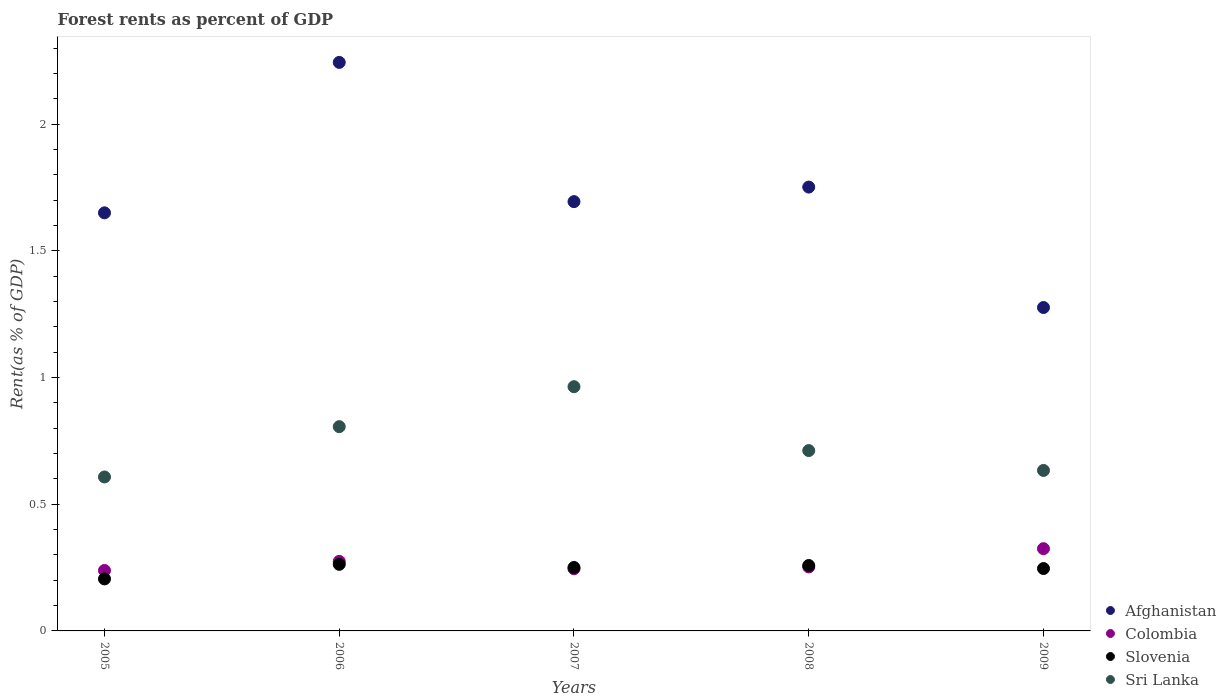Is the number of dotlines equal to the number of legend labels?
Give a very brief answer. Yes. What is the forest rent in Slovenia in 2005?
Make the answer very short. 0.21. Across all years, what is the maximum forest rent in Slovenia?
Give a very brief answer. 0.26. Across all years, what is the minimum forest rent in Sri Lanka?
Keep it short and to the point. 0.61. In which year was the forest rent in Afghanistan minimum?
Provide a succinct answer. 2009. What is the total forest rent in Afghanistan in the graph?
Keep it short and to the point. 8.62. What is the difference between the forest rent in Slovenia in 2007 and that in 2009?
Your answer should be very brief. 0. What is the difference between the forest rent in Colombia in 2005 and the forest rent in Afghanistan in 2008?
Ensure brevity in your answer.  -1.51. What is the average forest rent in Slovenia per year?
Your answer should be compact. 0.24. In the year 2007, what is the difference between the forest rent in Sri Lanka and forest rent in Afghanistan?
Keep it short and to the point. -0.73. In how many years, is the forest rent in Sri Lanka greater than 1.2 %?
Offer a terse response. 0. What is the ratio of the forest rent in Slovenia in 2005 to that in 2009?
Offer a very short reply. 0.83. Is the forest rent in Slovenia in 2006 less than that in 2008?
Your answer should be very brief. No. What is the difference between the highest and the second highest forest rent in Afghanistan?
Make the answer very short. 0.49. What is the difference between the highest and the lowest forest rent in Afghanistan?
Offer a terse response. 0.97. Is the sum of the forest rent in Slovenia in 2008 and 2009 greater than the maximum forest rent in Colombia across all years?
Your answer should be very brief. Yes. Is it the case that in every year, the sum of the forest rent in Sri Lanka and forest rent in Afghanistan  is greater than the sum of forest rent in Colombia and forest rent in Slovenia?
Provide a short and direct response. No. Is it the case that in every year, the sum of the forest rent in Sri Lanka and forest rent in Afghanistan  is greater than the forest rent in Colombia?
Give a very brief answer. Yes. Does the forest rent in Slovenia monotonically increase over the years?
Your response must be concise. No. Is the forest rent in Colombia strictly less than the forest rent in Sri Lanka over the years?
Ensure brevity in your answer.  Yes. Are the values on the major ticks of Y-axis written in scientific E-notation?
Provide a succinct answer. No. Does the graph contain grids?
Your response must be concise. No. What is the title of the graph?
Your answer should be very brief. Forest rents as percent of GDP. What is the label or title of the X-axis?
Your answer should be compact. Years. What is the label or title of the Y-axis?
Ensure brevity in your answer.  Rent(as % of GDP). What is the Rent(as % of GDP) of Afghanistan in 2005?
Ensure brevity in your answer.  1.65. What is the Rent(as % of GDP) of Colombia in 2005?
Give a very brief answer. 0.24. What is the Rent(as % of GDP) of Slovenia in 2005?
Your answer should be compact. 0.21. What is the Rent(as % of GDP) in Sri Lanka in 2005?
Your answer should be compact. 0.61. What is the Rent(as % of GDP) of Afghanistan in 2006?
Your response must be concise. 2.24. What is the Rent(as % of GDP) of Colombia in 2006?
Provide a succinct answer. 0.27. What is the Rent(as % of GDP) of Slovenia in 2006?
Your response must be concise. 0.26. What is the Rent(as % of GDP) in Sri Lanka in 2006?
Offer a very short reply. 0.81. What is the Rent(as % of GDP) of Afghanistan in 2007?
Offer a very short reply. 1.69. What is the Rent(as % of GDP) in Colombia in 2007?
Keep it short and to the point. 0.25. What is the Rent(as % of GDP) of Slovenia in 2007?
Your response must be concise. 0.25. What is the Rent(as % of GDP) in Sri Lanka in 2007?
Provide a succinct answer. 0.96. What is the Rent(as % of GDP) of Afghanistan in 2008?
Keep it short and to the point. 1.75. What is the Rent(as % of GDP) of Colombia in 2008?
Provide a short and direct response. 0.25. What is the Rent(as % of GDP) in Slovenia in 2008?
Keep it short and to the point. 0.26. What is the Rent(as % of GDP) of Sri Lanka in 2008?
Ensure brevity in your answer.  0.71. What is the Rent(as % of GDP) in Afghanistan in 2009?
Your answer should be compact. 1.28. What is the Rent(as % of GDP) of Colombia in 2009?
Provide a succinct answer. 0.32. What is the Rent(as % of GDP) in Slovenia in 2009?
Provide a succinct answer. 0.25. What is the Rent(as % of GDP) in Sri Lanka in 2009?
Provide a succinct answer. 0.63. Across all years, what is the maximum Rent(as % of GDP) in Afghanistan?
Make the answer very short. 2.24. Across all years, what is the maximum Rent(as % of GDP) of Colombia?
Offer a very short reply. 0.32. Across all years, what is the maximum Rent(as % of GDP) in Slovenia?
Your answer should be very brief. 0.26. Across all years, what is the maximum Rent(as % of GDP) of Sri Lanka?
Your answer should be very brief. 0.96. Across all years, what is the minimum Rent(as % of GDP) in Afghanistan?
Your answer should be very brief. 1.28. Across all years, what is the minimum Rent(as % of GDP) in Colombia?
Your answer should be compact. 0.24. Across all years, what is the minimum Rent(as % of GDP) of Slovenia?
Your answer should be very brief. 0.21. Across all years, what is the minimum Rent(as % of GDP) in Sri Lanka?
Provide a succinct answer. 0.61. What is the total Rent(as % of GDP) in Afghanistan in the graph?
Provide a short and direct response. 8.62. What is the total Rent(as % of GDP) of Colombia in the graph?
Provide a short and direct response. 1.34. What is the total Rent(as % of GDP) in Slovenia in the graph?
Offer a very short reply. 1.22. What is the total Rent(as % of GDP) in Sri Lanka in the graph?
Ensure brevity in your answer.  3.72. What is the difference between the Rent(as % of GDP) in Afghanistan in 2005 and that in 2006?
Ensure brevity in your answer.  -0.59. What is the difference between the Rent(as % of GDP) of Colombia in 2005 and that in 2006?
Your answer should be very brief. -0.04. What is the difference between the Rent(as % of GDP) of Slovenia in 2005 and that in 2006?
Offer a very short reply. -0.06. What is the difference between the Rent(as % of GDP) of Sri Lanka in 2005 and that in 2006?
Provide a short and direct response. -0.2. What is the difference between the Rent(as % of GDP) of Afghanistan in 2005 and that in 2007?
Your answer should be very brief. -0.04. What is the difference between the Rent(as % of GDP) in Colombia in 2005 and that in 2007?
Provide a short and direct response. -0.01. What is the difference between the Rent(as % of GDP) of Slovenia in 2005 and that in 2007?
Offer a terse response. -0.05. What is the difference between the Rent(as % of GDP) of Sri Lanka in 2005 and that in 2007?
Ensure brevity in your answer.  -0.36. What is the difference between the Rent(as % of GDP) of Afghanistan in 2005 and that in 2008?
Your answer should be compact. -0.1. What is the difference between the Rent(as % of GDP) of Colombia in 2005 and that in 2008?
Give a very brief answer. -0.01. What is the difference between the Rent(as % of GDP) in Slovenia in 2005 and that in 2008?
Offer a terse response. -0.05. What is the difference between the Rent(as % of GDP) of Sri Lanka in 2005 and that in 2008?
Your answer should be compact. -0.1. What is the difference between the Rent(as % of GDP) of Afghanistan in 2005 and that in 2009?
Provide a short and direct response. 0.37. What is the difference between the Rent(as % of GDP) of Colombia in 2005 and that in 2009?
Your response must be concise. -0.09. What is the difference between the Rent(as % of GDP) in Slovenia in 2005 and that in 2009?
Give a very brief answer. -0.04. What is the difference between the Rent(as % of GDP) in Sri Lanka in 2005 and that in 2009?
Provide a succinct answer. -0.03. What is the difference between the Rent(as % of GDP) of Afghanistan in 2006 and that in 2007?
Offer a very short reply. 0.55. What is the difference between the Rent(as % of GDP) of Colombia in 2006 and that in 2007?
Your answer should be very brief. 0.03. What is the difference between the Rent(as % of GDP) of Slovenia in 2006 and that in 2007?
Make the answer very short. 0.01. What is the difference between the Rent(as % of GDP) of Sri Lanka in 2006 and that in 2007?
Provide a short and direct response. -0.16. What is the difference between the Rent(as % of GDP) in Afghanistan in 2006 and that in 2008?
Ensure brevity in your answer.  0.49. What is the difference between the Rent(as % of GDP) of Colombia in 2006 and that in 2008?
Make the answer very short. 0.02. What is the difference between the Rent(as % of GDP) of Slovenia in 2006 and that in 2008?
Make the answer very short. 0. What is the difference between the Rent(as % of GDP) of Sri Lanka in 2006 and that in 2008?
Provide a succinct answer. 0.09. What is the difference between the Rent(as % of GDP) in Colombia in 2006 and that in 2009?
Give a very brief answer. -0.05. What is the difference between the Rent(as % of GDP) of Slovenia in 2006 and that in 2009?
Your response must be concise. 0.02. What is the difference between the Rent(as % of GDP) of Sri Lanka in 2006 and that in 2009?
Give a very brief answer. 0.17. What is the difference between the Rent(as % of GDP) of Afghanistan in 2007 and that in 2008?
Provide a succinct answer. -0.06. What is the difference between the Rent(as % of GDP) in Colombia in 2007 and that in 2008?
Make the answer very short. -0.01. What is the difference between the Rent(as % of GDP) in Slovenia in 2007 and that in 2008?
Your response must be concise. -0.01. What is the difference between the Rent(as % of GDP) of Sri Lanka in 2007 and that in 2008?
Your answer should be compact. 0.25. What is the difference between the Rent(as % of GDP) of Afghanistan in 2007 and that in 2009?
Keep it short and to the point. 0.42. What is the difference between the Rent(as % of GDP) in Colombia in 2007 and that in 2009?
Offer a terse response. -0.08. What is the difference between the Rent(as % of GDP) of Slovenia in 2007 and that in 2009?
Offer a terse response. 0. What is the difference between the Rent(as % of GDP) in Sri Lanka in 2007 and that in 2009?
Give a very brief answer. 0.33. What is the difference between the Rent(as % of GDP) in Afghanistan in 2008 and that in 2009?
Provide a succinct answer. 0.48. What is the difference between the Rent(as % of GDP) in Colombia in 2008 and that in 2009?
Your answer should be compact. -0.07. What is the difference between the Rent(as % of GDP) of Slovenia in 2008 and that in 2009?
Provide a short and direct response. 0.01. What is the difference between the Rent(as % of GDP) in Sri Lanka in 2008 and that in 2009?
Make the answer very short. 0.08. What is the difference between the Rent(as % of GDP) in Afghanistan in 2005 and the Rent(as % of GDP) in Colombia in 2006?
Provide a succinct answer. 1.38. What is the difference between the Rent(as % of GDP) in Afghanistan in 2005 and the Rent(as % of GDP) in Slovenia in 2006?
Your answer should be very brief. 1.39. What is the difference between the Rent(as % of GDP) in Afghanistan in 2005 and the Rent(as % of GDP) in Sri Lanka in 2006?
Offer a very short reply. 0.84. What is the difference between the Rent(as % of GDP) of Colombia in 2005 and the Rent(as % of GDP) of Slovenia in 2006?
Ensure brevity in your answer.  -0.02. What is the difference between the Rent(as % of GDP) in Colombia in 2005 and the Rent(as % of GDP) in Sri Lanka in 2006?
Your answer should be very brief. -0.57. What is the difference between the Rent(as % of GDP) of Slovenia in 2005 and the Rent(as % of GDP) of Sri Lanka in 2006?
Provide a short and direct response. -0.6. What is the difference between the Rent(as % of GDP) of Afghanistan in 2005 and the Rent(as % of GDP) of Colombia in 2007?
Offer a terse response. 1.41. What is the difference between the Rent(as % of GDP) of Afghanistan in 2005 and the Rent(as % of GDP) of Slovenia in 2007?
Your answer should be compact. 1.4. What is the difference between the Rent(as % of GDP) in Afghanistan in 2005 and the Rent(as % of GDP) in Sri Lanka in 2007?
Keep it short and to the point. 0.69. What is the difference between the Rent(as % of GDP) of Colombia in 2005 and the Rent(as % of GDP) of Slovenia in 2007?
Give a very brief answer. -0.01. What is the difference between the Rent(as % of GDP) in Colombia in 2005 and the Rent(as % of GDP) in Sri Lanka in 2007?
Ensure brevity in your answer.  -0.73. What is the difference between the Rent(as % of GDP) of Slovenia in 2005 and the Rent(as % of GDP) of Sri Lanka in 2007?
Offer a very short reply. -0.76. What is the difference between the Rent(as % of GDP) of Afghanistan in 2005 and the Rent(as % of GDP) of Colombia in 2008?
Ensure brevity in your answer.  1.4. What is the difference between the Rent(as % of GDP) of Afghanistan in 2005 and the Rent(as % of GDP) of Slovenia in 2008?
Offer a terse response. 1.39. What is the difference between the Rent(as % of GDP) in Afghanistan in 2005 and the Rent(as % of GDP) in Sri Lanka in 2008?
Offer a very short reply. 0.94. What is the difference between the Rent(as % of GDP) of Colombia in 2005 and the Rent(as % of GDP) of Slovenia in 2008?
Your answer should be compact. -0.02. What is the difference between the Rent(as % of GDP) of Colombia in 2005 and the Rent(as % of GDP) of Sri Lanka in 2008?
Keep it short and to the point. -0.47. What is the difference between the Rent(as % of GDP) in Slovenia in 2005 and the Rent(as % of GDP) in Sri Lanka in 2008?
Provide a short and direct response. -0.51. What is the difference between the Rent(as % of GDP) of Afghanistan in 2005 and the Rent(as % of GDP) of Colombia in 2009?
Your answer should be very brief. 1.33. What is the difference between the Rent(as % of GDP) in Afghanistan in 2005 and the Rent(as % of GDP) in Slovenia in 2009?
Keep it short and to the point. 1.4. What is the difference between the Rent(as % of GDP) of Colombia in 2005 and the Rent(as % of GDP) of Slovenia in 2009?
Provide a short and direct response. -0.01. What is the difference between the Rent(as % of GDP) in Colombia in 2005 and the Rent(as % of GDP) in Sri Lanka in 2009?
Offer a very short reply. -0.39. What is the difference between the Rent(as % of GDP) in Slovenia in 2005 and the Rent(as % of GDP) in Sri Lanka in 2009?
Offer a terse response. -0.43. What is the difference between the Rent(as % of GDP) in Afghanistan in 2006 and the Rent(as % of GDP) in Colombia in 2007?
Make the answer very short. 2. What is the difference between the Rent(as % of GDP) in Afghanistan in 2006 and the Rent(as % of GDP) in Slovenia in 2007?
Offer a terse response. 1.99. What is the difference between the Rent(as % of GDP) in Afghanistan in 2006 and the Rent(as % of GDP) in Sri Lanka in 2007?
Ensure brevity in your answer.  1.28. What is the difference between the Rent(as % of GDP) of Colombia in 2006 and the Rent(as % of GDP) of Slovenia in 2007?
Keep it short and to the point. 0.02. What is the difference between the Rent(as % of GDP) in Colombia in 2006 and the Rent(as % of GDP) in Sri Lanka in 2007?
Your answer should be compact. -0.69. What is the difference between the Rent(as % of GDP) in Slovenia in 2006 and the Rent(as % of GDP) in Sri Lanka in 2007?
Provide a succinct answer. -0.7. What is the difference between the Rent(as % of GDP) of Afghanistan in 2006 and the Rent(as % of GDP) of Colombia in 2008?
Provide a succinct answer. 1.99. What is the difference between the Rent(as % of GDP) in Afghanistan in 2006 and the Rent(as % of GDP) in Slovenia in 2008?
Ensure brevity in your answer.  1.99. What is the difference between the Rent(as % of GDP) of Afghanistan in 2006 and the Rent(as % of GDP) of Sri Lanka in 2008?
Ensure brevity in your answer.  1.53. What is the difference between the Rent(as % of GDP) in Colombia in 2006 and the Rent(as % of GDP) in Slovenia in 2008?
Your answer should be very brief. 0.02. What is the difference between the Rent(as % of GDP) in Colombia in 2006 and the Rent(as % of GDP) in Sri Lanka in 2008?
Offer a terse response. -0.44. What is the difference between the Rent(as % of GDP) of Slovenia in 2006 and the Rent(as % of GDP) of Sri Lanka in 2008?
Offer a terse response. -0.45. What is the difference between the Rent(as % of GDP) in Afghanistan in 2006 and the Rent(as % of GDP) in Colombia in 2009?
Your answer should be very brief. 1.92. What is the difference between the Rent(as % of GDP) in Afghanistan in 2006 and the Rent(as % of GDP) in Slovenia in 2009?
Your response must be concise. 2. What is the difference between the Rent(as % of GDP) of Afghanistan in 2006 and the Rent(as % of GDP) of Sri Lanka in 2009?
Keep it short and to the point. 1.61. What is the difference between the Rent(as % of GDP) of Colombia in 2006 and the Rent(as % of GDP) of Slovenia in 2009?
Keep it short and to the point. 0.03. What is the difference between the Rent(as % of GDP) in Colombia in 2006 and the Rent(as % of GDP) in Sri Lanka in 2009?
Your response must be concise. -0.36. What is the difference between the Rent(as % of GDP) in Slovenia in 2006 and the Rent(as % of GDP) in Sri Lanka in 2009?
Your answer should be very brief. -0.37. What is the difference between the Rent(as % of GDP) of Afghanistan in 2007 and the Rent(as % of GDP) of Colombia in 2008?
Provide a succinct answer. 1.44. What is the difference between the Rent(as % of GDP) in Afghanistan in 2007 and the Rent(as % of GDP) in Slovenia in 2008?
Offer a terse response. 1.44. What is the difference between the Rent(as % of GDP) in Afghanistan in 2007 and the Rent(as % of GDP) in Sri Lanka in 2008?
Make the answer very short. 0.98. What is the difference between the Rent(as % of GDP) of Colombia in 2007 and the Rent(as % of GDP) of Slovenia in 2008?
Your answer should be very brief. -0.01. What is the difference between the Rent(as % of GDP) in Colombia in 2007 and the Rent(as % of GDP) in Sri Lanka in 2008?
Make the answer very short. -0.47. What is the difference between the Rent(as % of GDP) in Slovenia in 2007 and the Rent(as % of GDP) in Sri Lanka in 2008?
Your response must be concise. -0.46. What is the difference between the Rent(as % of GDP) of Afghanistan in 2007 and the Rent(as % of GDP) of Colombia in 2009?
Keep it short and to the point. 1.37. What is the difference between the Rent(as % of GDP) in Afghanistan in 2007 and the Rent(as % of GDP) in Slovenia in 2009?
Give a very brief answer. 1.45. What is the difference between the Rent(as % of GDP) in Afghanistan in 2007 and the Rent(as % of GDP) in Sri Lanka in 2009?
Offer a very short reply. 1.06. What is the difference between the Rent(as % of GDP) of Colombia in 2007 and the Rent(as % of GDP) of Slovenia in 2009?
Your answer should be compact. -0. What is the difference between the Rent(as % of GDP) of Colombia in 2007 and the Rent(as % of GDP) of Sri Lanka in 2009?
Provide a succinct answer. -0.39. What is the difference between the Rent(as % of GDP) in Slovenia in 2007 and the Rent(as % of GDP) in Sri Lanka in 2009?
Ensure brevity in your answer.  -0.38. What is the difference between the Rent(as % of GDP) of Afghanistan in 2008 and the Rent(as % of GDP) of Colombia in 2009?
Provide a succinct answer. 1.43. What is the difference between the Rent(as % of GDP) in Afghanistan in 2008 and the Rent(as % of GDP) in Slovenia in 2009?
Ensure brevity in your answer.  1.51. What is the difference between the Rent(as % of GDP) of Afghanistan in 2008 and the Rent(as % of GDP) of Sri Lanka in 2009?
Give a very brief answer. 1.12. What is the difference between the Rent(as % of GDP) in Colombia in 2008 and the Rent(as % of GDP) in Slovenia in 2009?
Ensure brevity in your answer.  0.01. What is the difference between the Rent(as % of GDP) in Colombia in 2008 and the Rent(as % of GDP) in Sri Lanka in 2009?
Make the answer very short. -0.38. What is the difference between the Rent(as % of GDP) of Slovenia in 2008 and the Rent(as % of GDP) of Sri Lanka in 2009?
Your answer should be very brief. -0.38. What is the average Rent(as % of GDP) of Afghanistan per year?
Your response must be concise. 1.72. What is the average Rent(as % of GDP) of Colombia per year?
Your answer should be very brief. 0.27. What is the average Rent(as % of GDP) in Slovenia per year?
Make the answer very short. 0.24. What is the average Rent(as % of GDP) of Sri Lanka per year?
Keep it short and to the point. 0.74. In the year 2005, what is the difference between the Rent(as % of GDP) of Afghanistan and Rent(as % of GDP) of Colombia?
Your answer should be compact. 1.41. In the year 2005, what is the difference between the Rent(as % of GDP) in Afghanistan and Rent(as % of GDP) in Slovenia?
Ensure brevity in your answer.  1.45. In the year 2005, what is the difference between the Rent(as % of GDP) in Afghanistan and Rent(as % of GDP) in Sri Lanka?
Provide a succinct answer. 1.04. In the year 2005, what is the difference between the Rent(as % of GDP) of Colombia and Rent(as % of GDP) of Slovenia?
Make the answer very short. 0.03. In the year 2005, what is the difference between the Rent(as % of GDP) of Colombia and Rent(as % of GDP) of Sri Lanka?
Keep it short and to the point. -0.37. In the year 2005, what is the difference between the Rent(as % of GDP) of Slovenia and Rent(as % of GDP) of Sri Lanka?
Keep it short and to the point. -0.4. In the year 2006, what is the difference between the Rent(as % of GDP) in Afghanistan and Rent(as % of GDP) in Colombia?
Give a very brief answer. 1.97. In the year 2006, what is the difference between the Rent(as % of GDP) in Afghanistan and Rent(as % of GDP) in Slovenia?
Offer a very short reply. 1.98. In the year 2006, what is the difference between the Rent(as % of GDP) of Afghanistan and Rent(as % of GDP) of Sri Lanka?
Provide a short and direct response. 1.44. In the year 2006, what is the difference between the Rent(as % of GDP) of Colombia and Rent(as % of GDP) of Slovenia?
Make the answer very short. 0.01. In the year 2006, what is the difference between the Rent(as % of GDP) in Colombia and Rent(as % of GDP) in Sri Lanka?
Your answer should be very brief. -0.53. In the year 2006, what is the difference between the Rent(as % of GDP) in Slovenia and Rent(as % of GDP) in Sri Lanka?
Give a very brief answer. -0.54. In the year 2007, what is the difference between the Rent(as % of GDP) in Afghanistan and Rent(as % of GDP) in Colombia?
Your answer should be very brief. 1.45. In the year 2007, what is the difference between the Rent(as % of GDP) of Afghanistan and Rent(as % of GDP) of Slovenia?
Give a very brief answer. 1.44. In the year 2007, what is the difference between the Rent(as % of GDP) of Afghanistan and Rent(as % of GDP) of Sri Lanka?
Your answer should be very brief. 0.73. In the year 2007, what is the difference between the Rent(as % of GDP) of Colombia and Rent(as % of GDP) of Slovenia?
Offer a terse response. -0.01. In the year 2007, what is the difference between the Rent(as % of GDP) of Colombia and Rent(as % of GDP) of Sri Lanka?
Make the answer very short. -0.72. In the year 2007, what is the difference between the Rent(as % of GDP) in Slovenia and Rent(as % of GDP) in Sri Lanka?
Make the answer very short. -0.71. In the year 2008, what is the difference between the Rent(as % of GDP) in Afghanistan and Rent(as % of GDP) in Colombia?
Your response must be concise. 1.5. In the year 2008, what is the difference between the Rent(as % of GDP) of Afghanistan and Rent(as % of GDP) of Slovenia?
Ensure brevity in your answer.  1.49. In the year 2008, what is the difference between the Rent(as % of GDP) of Afghanistan and Rent(as % of GDP) of Sri Lanka?
Your answer should be very brief. 1.04. In the year 2008, what is the difference between the Rent(as % of GDP) of Colombia and Rent(as % of GDP) of Slovenia?
Make the answer very short. -0.01. In the year 2008, what is the difference between the Rent(as % of GDP) in Colombia and Rent(as % of GDP) in Sri Lanka?
Offer a terse response. -0.46. In the year 2008, what is the difference between the Rent(as % of GDP) in Slovenia and Rent(as % of GDP) in Sri Lanka?
Offer a terse response. -0.45. In the year 2009, what is the difference between the Rent(as % of GDP) in Afghanistan and Rent(as % of GDP) in Colombia?
Offer a very short reply. 0.95. In the year 2009, what is the difference between the Rent(as % of GDP) in Afghanistan and Rent(as % of GDP) in Slovenia?
Ensure brevity in your answer.  1.03. In the year 2009, what is the difference between the Rent(as % of GDP) of Afghanistan and Rent(as % of GDP) of Sri Lanka?
Keep it short and to the point. 0.64. In the year 2009, what is the difference between the Rent(as % of GDP) of Colombia and Rent(as % of GDP) of Slovenia?
Your answer should be compact. 0.08. In the year 2009, what is the difference between the Rent(as % of GDP) of Colombia and Rent(as % of GDP) of Sri Lanka?
Provide a succinct answer. -0.31. In the year 2009, what is the difference between the Rent(as % of GDP) in Slovenia and Rent(as % of GDP) in Sri Lanka?
Make the answer very short. -0.39. What is the ratio of the Rent(as % of GDP) in Afghanistan in 2005 to that in 2006?
Your answer should be compact. 0.74. What is the ratio of the Rent(as % of GDP) of Colombia in 2005 to that in 2006?
Give a very brief answer. 0.87. What is the ratio of the Rent(as % of GDP) of Slovenia in 2005 to that in 2006?
Offer a terse response. 0.78. What is the ratio of the Rent(as % of GDP) of Sri Lanka in 2005 to that in 2006?
Provide a succinct answer. 0.75. What is the ratio of the Rent(as % of GDP) of Afghanistan in 2005 to that in 2007?
Give a very brief answer. 0.97. What is the ratio of the Rent(as % of GDP) of Colombia in 2005 to that in 2007?
Ensure brevity in your answer.  0.97. What is the ratio of the Rent(as % of GDP) in Slovenia in 2005 to that in 2007?
Offer a very short reply. 0.82. What is the ratio of the Rent(as % of GDP) in Sri Lanka in 2005 to that in 2007?
Give a very brief answer. 0.63. What is the ratio of the Rent(as % of GDP) in Afghanistan in 2005 to that in 2008?
Provide a succinct answer. 0.94. What is the ratio of the Rent(as % of GDP) of Colombia in 2005 to that in 2008?
Make the answer very short. 0.94. What is the ratio of the Rent(as % of GDP) of Slovenia in 2005 to that in 2008?
Provide a short and direct response. 0.8. What is the ratio of the Rent(as % of GDP) of Sri Lanka in 2005 to that in 2008?
Your response must be concise. 0.85. What is the ratio of the Rent(as % of GDP) in Afghanistan in 2005 to that in 2009?
Your answer should be very brief. 1.29. What is the ratio of the Rent(as % of GDP) of Colombia in 2005 to that in 2009?
Keep it short and to the point. 0.74. What is the ratio of the Rent(as % of GDP) of Slovenia in 2005 to that in 2009?
Offer a terse response. 0.83. What is the ratio of the Rent(as % of GDP) in Sri Lanka in 2005 to that in 2009?
Provide a short and direct response. 0.96. What is the ratio of the Rent(as % of GDP) in Afghanistan in 2006 to that in 2007?
Your response must be concise. 1.32. What is the ratio of the Rent(as % of GDP) of Colombia in 2006 to that in 2007?
Your answer should be very brief. 1.12. What is the ratio of the Rent(as % of GDP) in Slovenia in 2006 to that in 2007?
Give a very brief answer. 1.05. What is the ratio of the Rent(as % of GDP) of Sri Lanka in 2006 to that in 2007?
Offer a very short reply. 0.84. What is the ratio of the Rent(as % of GDP) in Afghanistan in 2006 to that in 2008?
Your answer should be very brief. 1.28. What is the ratio of the Rent(as % of GDP) of Colombia in 2006 to that in 2008?
Ensure brevity in your answer.  1.09. What is the ratio of the Rent(as % of GDP) of Sri Lanka in 2006 to that in 2008?
Ensure brevity in your answer.  1.13. What is the ratio of the Rent(as % of GDP) in Afghanistan in 2006 to that in 2009?
Offer a terse response. 1.76. What is the ratio of the Rent(as % of GDP) of Colombia in 2006 to that in 2009?
Provide a short and direct response. 0.85. What is the ratio of the Rent(as % of GDP) in Slovenia in 2006 to that in 2009?
Your answer should be very brief. 1.07. What is the ratio of the Rent(as % of GDP) in Sri Lanka in 2006 to that in 2009?
Give a very brief answer. 1.27. What is the ratio of the Rent(as % of GDP) of Afghanistan in 2007 to that in 2008?
Provide a short and direct response. 0.97. What is the ratio of the Rent(as % of GDP) in Colombia in 2007 to that in 2008?
Your answer should be very brief. 0.97. What is the ratio of the Rent(as % of GDP) in Slovenia in 2007 to that in 2008?
Ensure brevity in your answer.  0.97. What is the ratio of the Rent(as % of GDP) in Sri Lanka in 2007 to that in 2008?
Provide a succinct answer. 1.35. What is the ratio of the Rent(as % of GDP) of Afghanistan in 2007 to that in 2009?
Keep it short and to the point. 1.33. What is the ratio of the Rent(as % of GDP) in Colombia in 2007 to that in 2009?
Offer a very short reply. 0.76. What is the ratio of the Rent(as % of GDP) in Slovenia in 2007 to that in 2009?
Keep it short and to the point. 1.02. What is the ratio of the Rent(as % of GDP) in Sri Lanka in 2007 to that in 2009?
Provide a short and direct response. 1.52. What is the ratio of the Rent(as % of GDP) of Afghanistan in 2008 to that in 2009?
Offer a terse response. 1.37. What is the ratio of the Rent(as % of GDP) in Colombia in 2008 to that in 2009?
Your response must be concise. 0.78. What is the ratio of the Rent(as % of GDP) in Slovenia in 2008 to that in 2009?
Ensure brevity in your answer.  1.05. What is the ratio of the Rent(as % of GDP) in Sri Lanka in 2008 to that in 2009?
Offer a terse response. 1.12. What is the difference between the highest and the second highest Rent(as % of GDP) of Afghanistan?
Give a very brief answer. 0.49. What is the difference between the highest and the second highest Rent(as % of GDP) in Colombia?
Offer a terse response. 0.05. What is the difference between the highest and the second highest Rent(as % of GDP) of Slovenia?
Provide a short and direct response. 0. What is the difference between the highest and the second highest Rent(as % of GDP) of Sri Lanka?
Your response must be concise. 0.16. What is the difference between the highest and the lowest Rent(as % of GDP) in Afghanistan?
Give a very brief answer. 0.97. What is the difference between the highest and the lowest Rent(as % of GDP) of Colombia?
Provide a succinct answer. 0.09. What is the difference between the highest and the lowest Rent(as % of GDP) in Slovenia?
Your answer should be very brief. 0.06. What is the difference between the highest and the lowest Rent(as % of GDP) in Sri Lanka?
Provide a short and direct response. 0.36. 